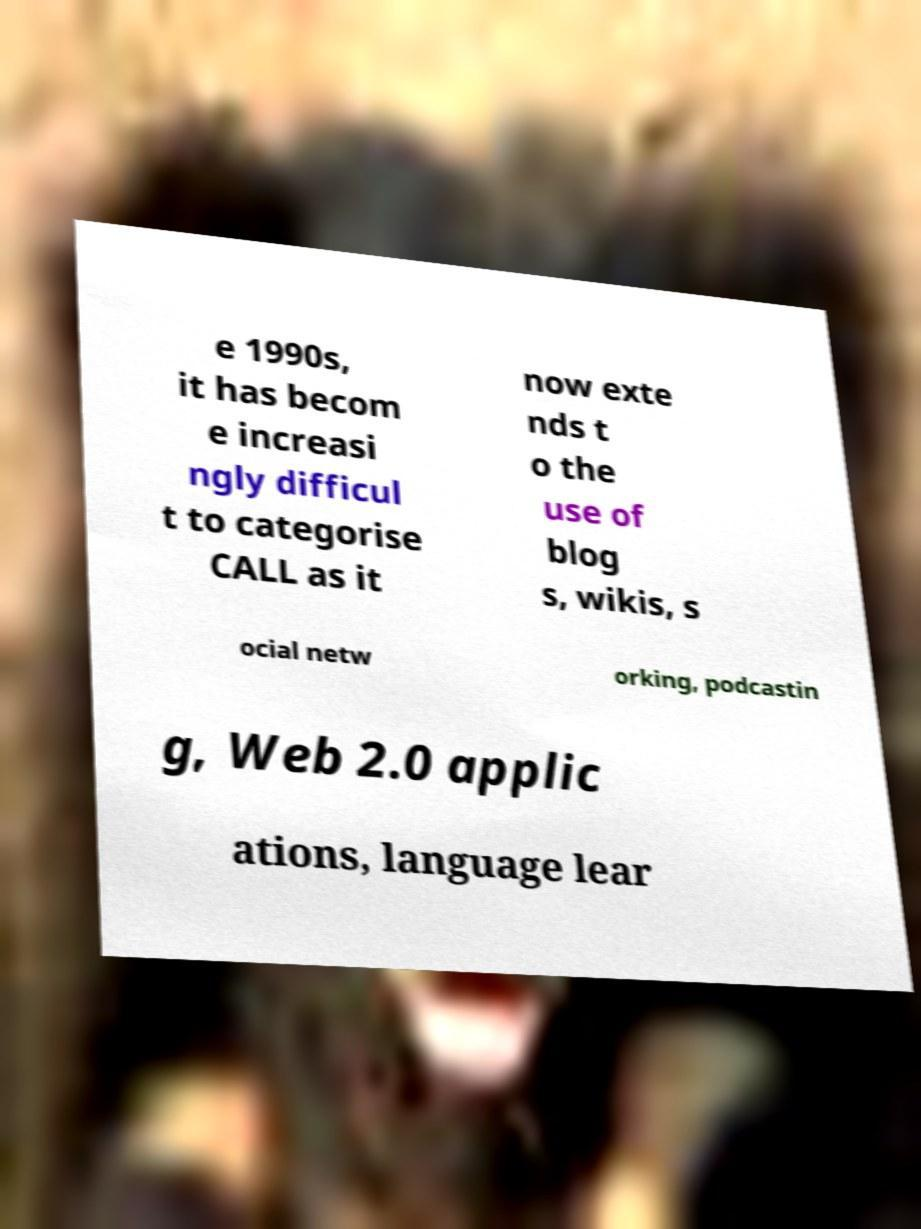Could you assist in decoding the text presented in this image and type it out clearly? Certainly! The text in the image appears to be a fragment discussing the evolution of Computer-Assisted Language Learning (CALL). Unfortunately, the visible parts of the text are incomplete, leading to sentences such as '...e 1990s, it has becom e increasi ngly difficul t to categori se CALL as it now exte nds t o the use of blog s, wikis, s ocial netw orking, podcastin g, Web 2.0 applic ations, language lear', which may be referencing the integration of new technologies and platforms in language education. 